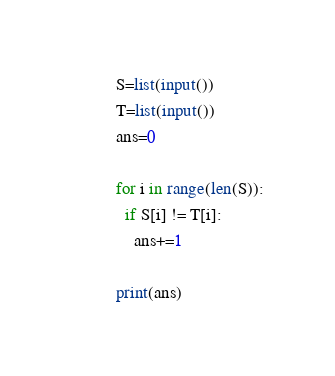<code> <loc_0><loc_0><loc_500><loc_500><_Python_>S=list(input())
T=list(input())
ans=0

for i in range(len(S)):
  if S[i] != T[i]:
    ans+=1

print(ans)</code> 